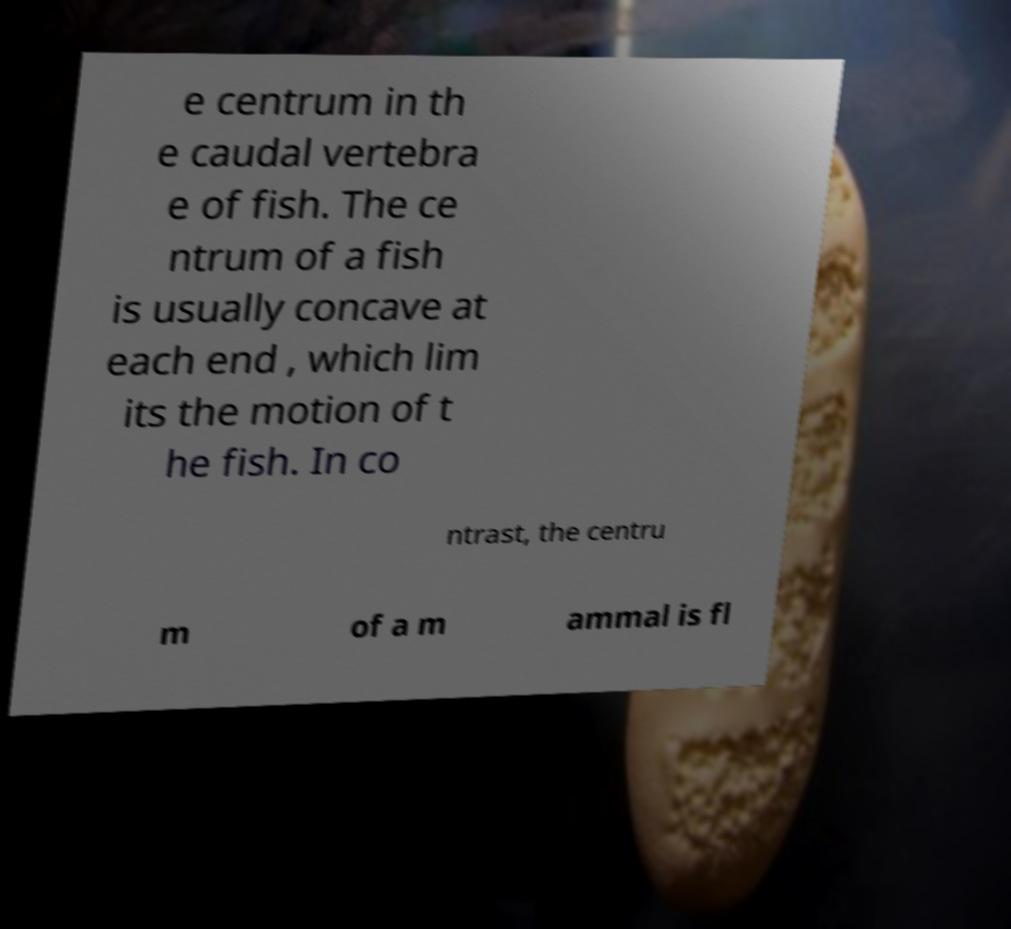Could you assist in decoding the text presented in this image and type it out clearly? e centrum in th e caudal vertebra e of fish. The ce ntrum of a fish is usually concave at each end , which lim its the motion of t he fish. In co ntrast, the centru m of a m ammal is fl 